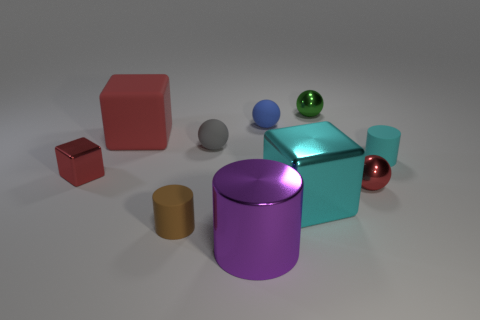Subtract all small cylinders. How many cylinders are left? 1 Subtract all cyan cylinders. How many cylinders are left? 2 Subtract 2 cubes. How many cubes are left? 1 Subtract all cubes. How many objects are left? 7 Subtract all shiny cylinders. Subtract all cubes. How many objects are left? 6 Add 5 purple metallic cylinders. How many purple metallic cylinders are left? 6 Add 5 green shiny balls. How many green shiny balls exist? 6 Subtract 0 green cylinders. How many objects are left? 10 Subtract all brown cubes. Subtract all brown balls. How many cubes are left? 3 Subtract all red cylinders. How many cyan blocks are left? 1 